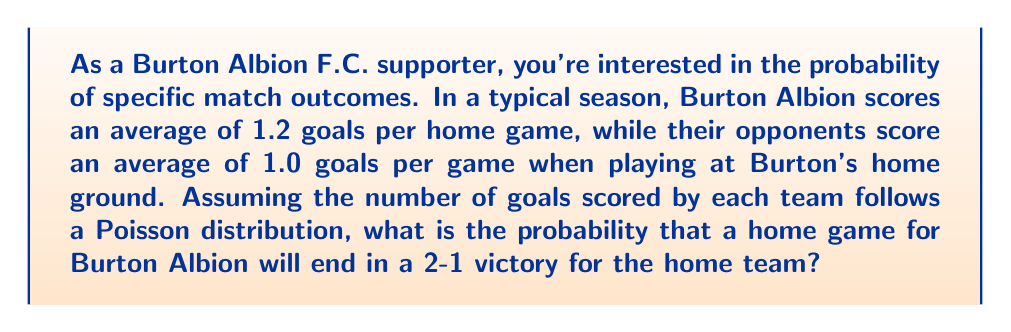Help me with this question. To solve this problem, we need to use the Poisson distribution for both Burton Albion's goals and their opponents' goals. The Poisson distribution is given by the formula:

$$P(X=k) = \frac{e^{-\lambda} \lambda^k}{k!}$$

Where:
$\lambda$ is the average number of events in the interval
$k$ is the number of events we're calculating the probability for
$e$ is Euler's number (approximately 2.71828)

Let's break this down step-by-step:

1. For Burton Albion (home team):
   $\lambda_1 = 1.2$ (average goals per home game)
   $k_1 = 2$ (we want them to score 2 goals)

2. For the opponents:
   $\lambda_2 = 1.0$ (average goals when playing at Burton's home)
   $k_2 = 1$ (we want them to score 1 goal)

3. Calculate the probability of Burton Albion scoring exactly 2 goals:
   $$P(X_1=2) = \frac{e^{-1.2} 1.2^2}{2!} = \frac{e^{-1.2} 1.44}{2} \approx 0.2169$$

4. Calculate the probability of the opponents scoring exactly 1 goal:
   $$P(X_2=1) = \frac{e^{-1.0} 1.0^1}{1!} = e^{-1.0} \approx 0.3679$$

5. Since these events are independent, we multiply the probabilities:
   $$P(\text{2-1 victory}) = P(X_1=2) \times P(X_2=1) \approx 0.2169 \times 0.3679 \approx 0.0798$$
Answer: The probability of a Burton Albion home game ending in a 2-1 victory for the home team is approximately $0.0798$ or $7.98\%$. 